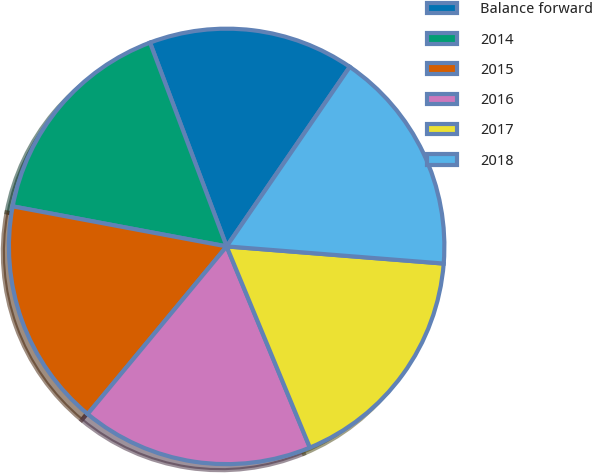Convert chart. <chart><loc_0><loc_0><loc_500><loc_500><pie_chart><fcel>Balance forward<fcel>2014<fcel>2015<fcel>2016<fcel>2017<fcel>2018<nl><fcel>15.29%<fcel>16.33%<fcel>16.93%<fcel>17.26%<fcel>17.5%<fcel>16.69%<nl></chart> 